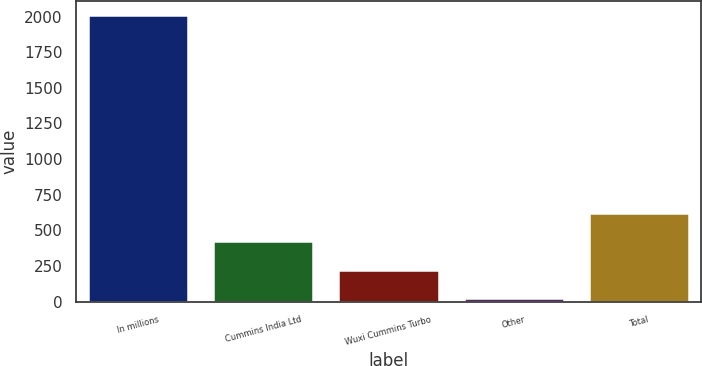Convert chart to OTSL. <chart><loc_0><loc_0><loc_500><loc_500><bar_chart><fcel>In millions<fcel>Cummins India Ltd<fcel>Wuxi Cummins Turbo<fcel>Other<fcel>Total<nl><fcel>2009<fcel>422.6<fcel>224.3<fcel>26<fcel>620.9<nl></chart> 